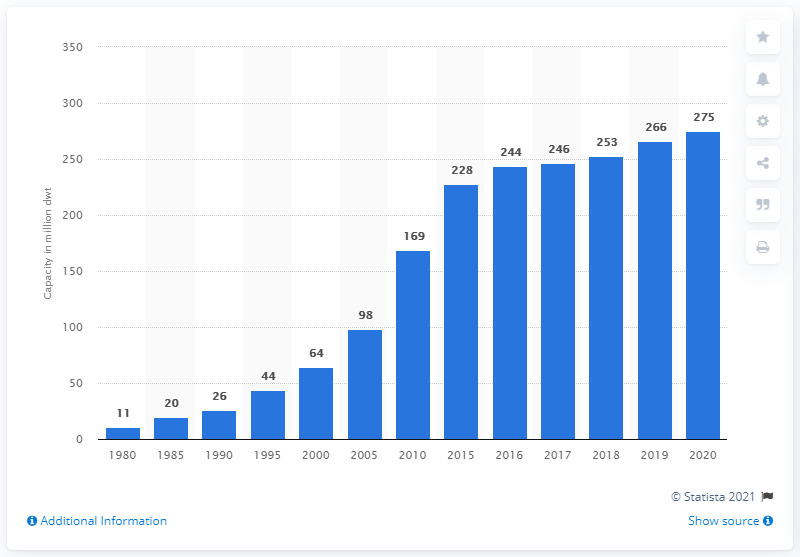Point out several critical features in this image. As of 2020, the world's merchant container ship fleet had a capacity of approximately 275. 